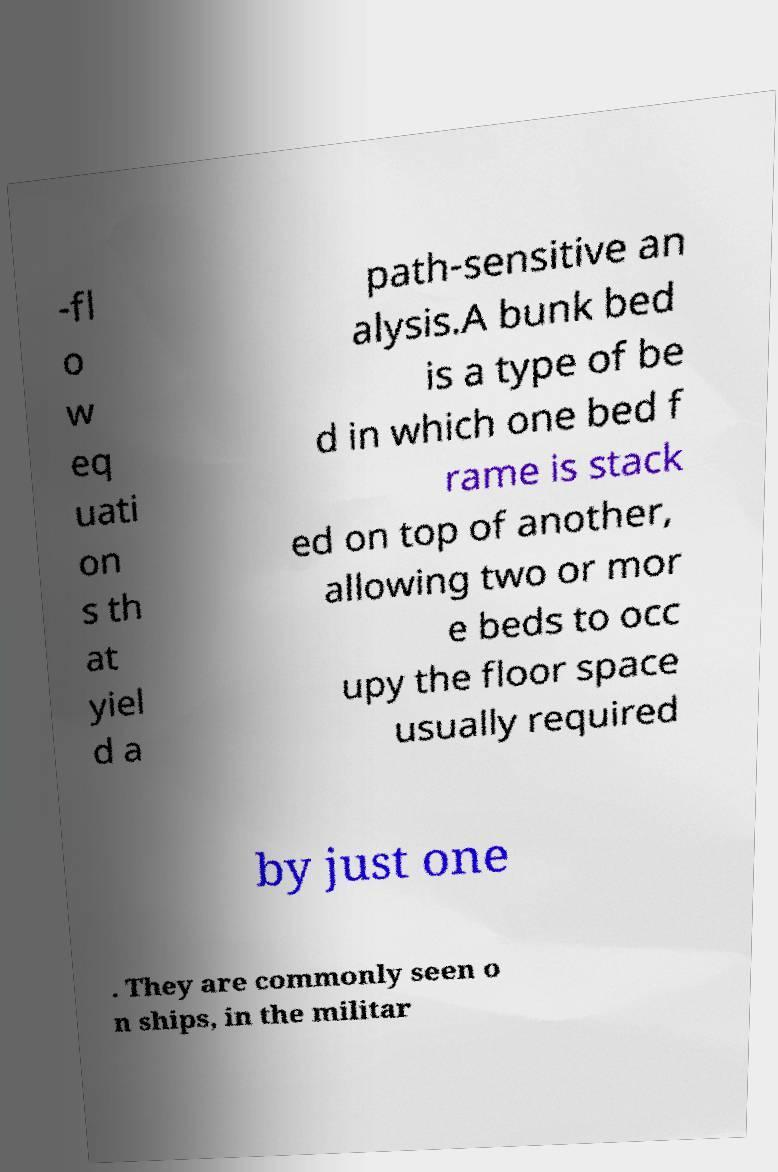Could you extract and type out the text from this image? -fl o w eq uati on s th at yiel d a path-sensitive an alysis.A bunk bed is a type of be d in which one bed f rame is stack ed on top of another, allowing two or mor e beds to occ upy the floor space usually required by just one . They are commonly seen o n ships, in the militar 